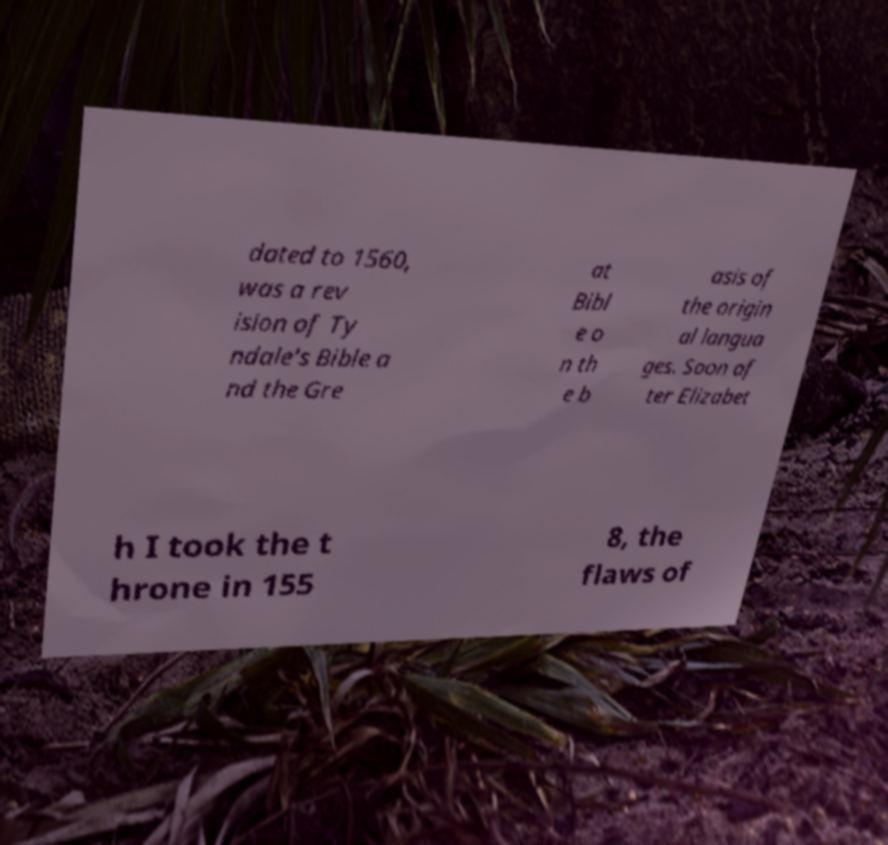Can you accurately transcribe the text from the provided image for me? dated to 1560, was a rev ision of Ty ndale's Bible a nd the Gre at Bibl e o n th e b asis of the origin al langua ges. Soon af ter Elizabet h I took the t hrone in 155 8, the flaws of 